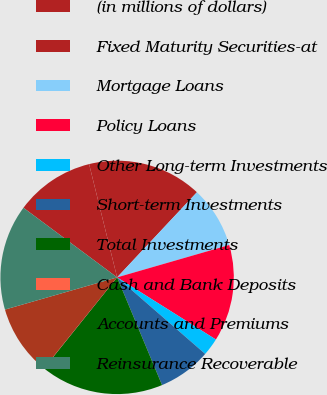<chart> <loc_0><loc_0><loc_500><loc_500><pie_chart><fcel>(in millions of dollars)<fcel>Fixed Maturity Securities-at<fcel>Mortgage Loans<fcel>Policy Loans<fcel>Other Long-term Investments<fcel>Short-term Investments<fcel>Total Investments<fcel>Cash and Bank Deposits<fcel>Accounts and Premiums<fcel>Reinsurance Recoverable<nl><fcel>10.97%<fcel>15.84%<fcel>8.54%<fcel>13.41%<fcel>2.45%<fcel>7.32%<fcel>17.06%<fcel>0.02%<fcel>9.76%<fcel>14.62%<nl></chart> 